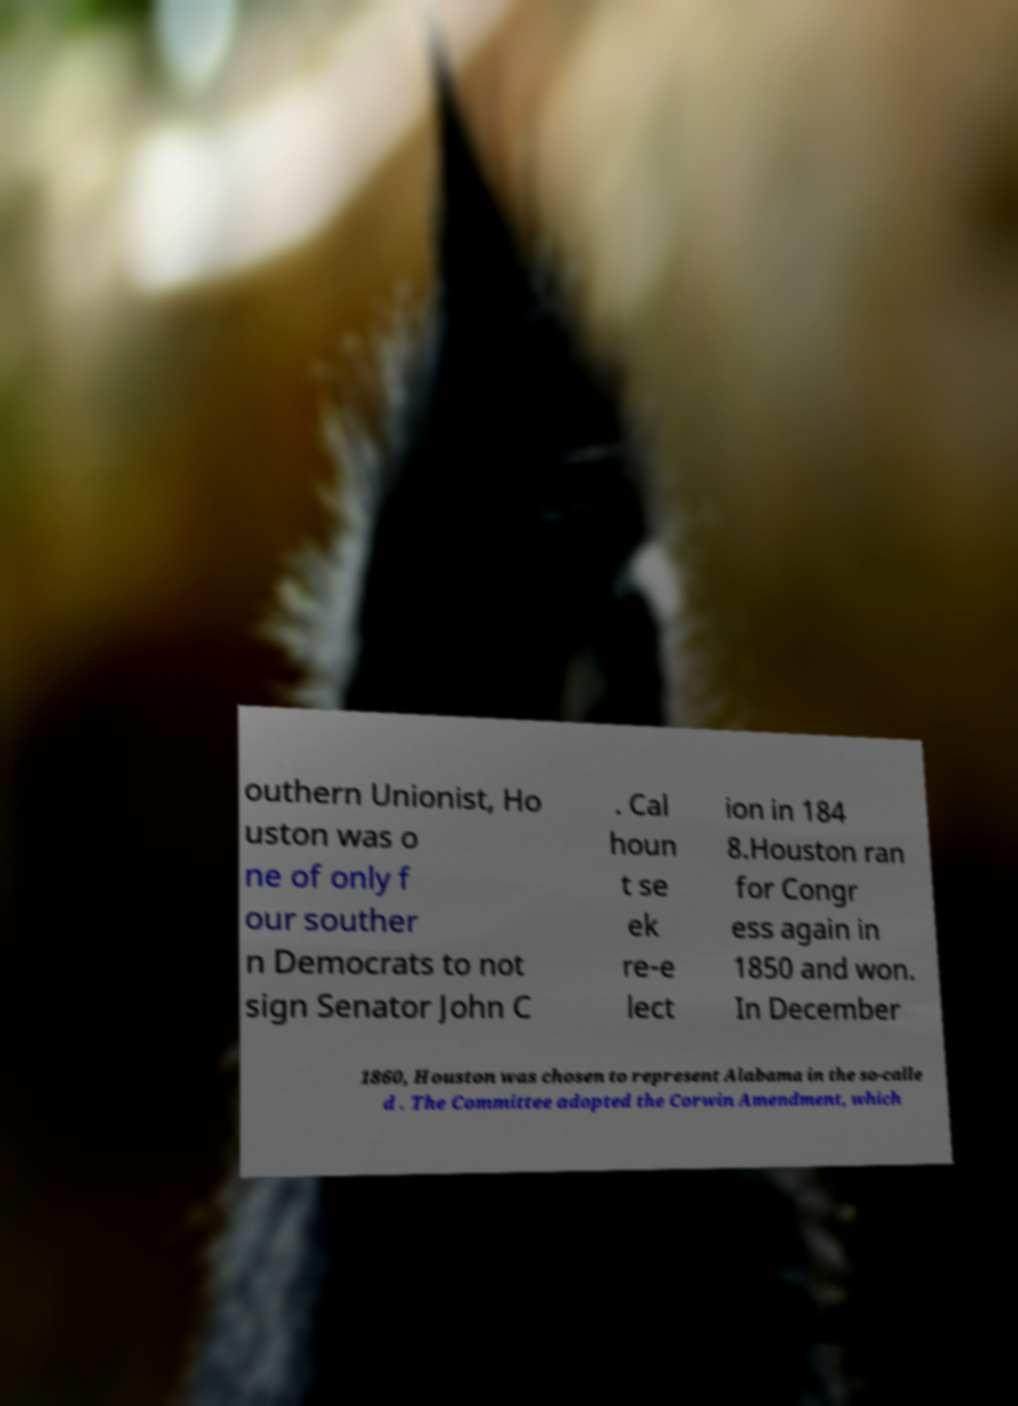Please read and relay the text visible in this image. What does it say? outhern Unionist, Ho uston was o ne of only f our souther n Democrats to not sign Senator John C . Cal houn t se ek re-e lect ion in 184 8.Houston ran for Congr ess again in 1850 and won. In December 1860, Houston was chosen to represent Alabama in the so-calle d . The Committee adopted the Corwin Amendment, which 